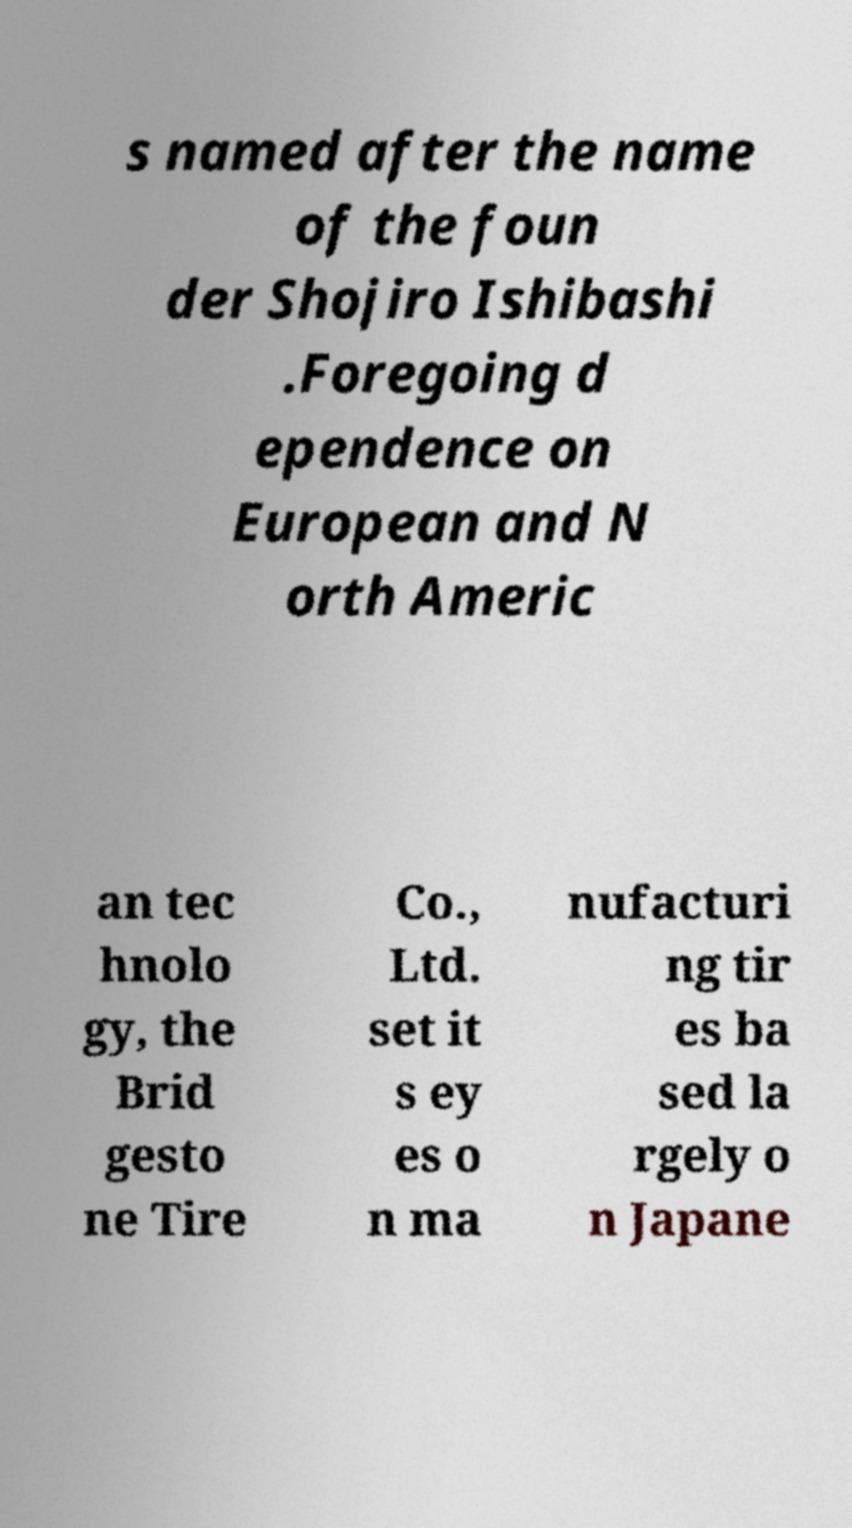Could you assist in decoding the text presented in this image and type it out clearly? s named after the name of the foun der Shojiro Ishibashi .Foregoing d ependence on European and N orth Americ an tec hnolo gy, the Brid gesto ne Tire Co., Ltd. set it s ey es o n ma nufacturi ng tir es ba sed la rgely o n Japane 